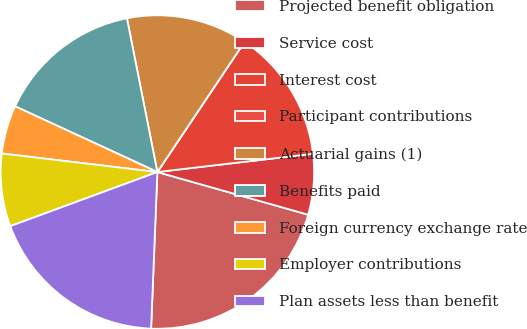Convert chart to OTSL. <chart><loc_0><loc_0><loc_500><loc_500><pie_chart><fcel>Projected benefit obligation<fcel>Service cost<fcel>Interest cost<fcel>Participant contributions<fcel>Actuarial gains (1)<fcel>Benefits paid<fcel>Foreign currency exchange rate<fcel>Employer contributions<fcel>Plan assets less than benefit<nl><fcel>21.25%<fcel>6.25%<fcel>13.75%<fcel>0.0%<fcel>12.5%<fcel>15.0%<fcel>5.0%<fcel>7.5%<fcel>18.75%<nl></chart> 